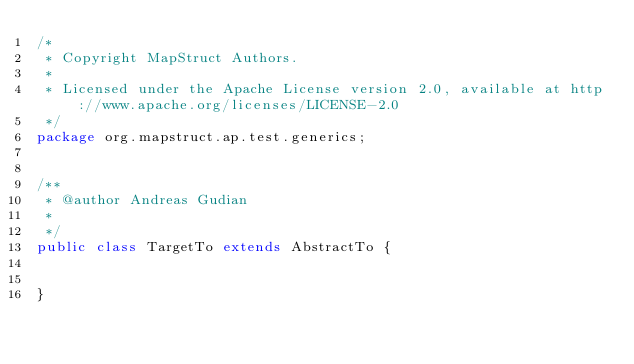Convert code to text. <code><loc_0><loc_0><loc_500><loc_500><_Java_>/*
 * Copyright MapStruct Authors.
 *
 * Licensed under the Apache License version 2.0, available at http://www.apache.org/licenses/LICENSE-2.0
 */
package org.mapstruct.ap.test.generics;


/**
 * @author Andreas Gudian
 *
 */
public class TargetTo extends AbstractTo {


}
</code> 